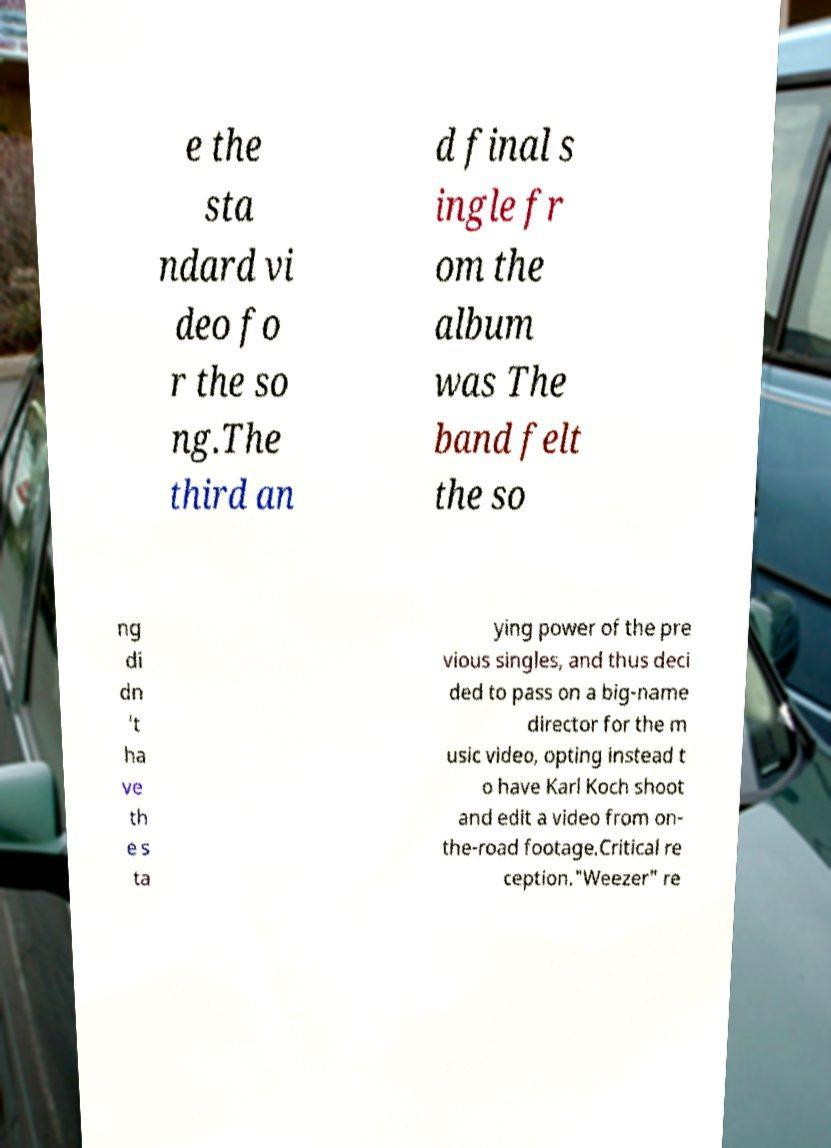Could you extract and type out the text from this image? e the sta ndard vi deo fo r the so ng.The third an d final s ingle fr om the album was The band felt the so ng di dn 't ha ve th e s ta ying power of the pre vious singles, and thus deci ded to pass on a big-name director for the m usic video, opting instead t o have Karl Koch shoot and edit a video from on- the-road footage.Critical re ception."Weezer" re 